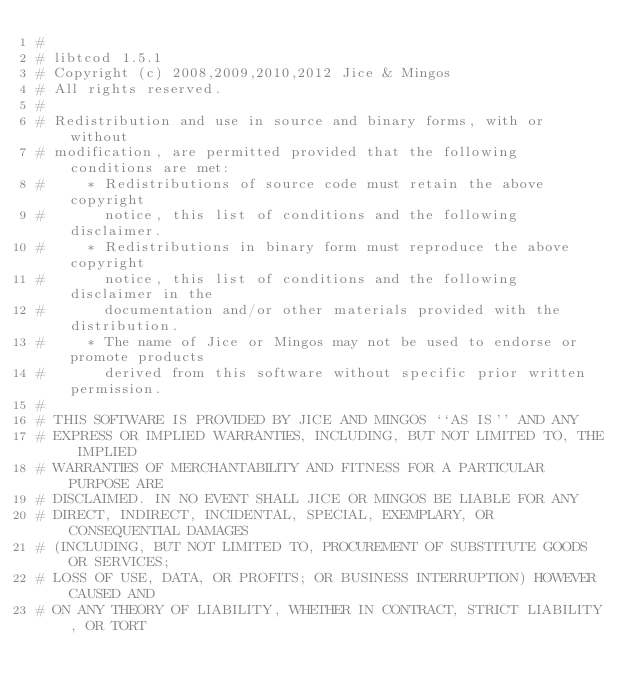Convert code to text. <code><loc_0><loc_0><loc_500><loc_500><_Nim_>#
# libtcod 1.5.1
# Copyright (c) 2008,2009,2010,2012 Jice & Mingos
# All rights reserved.
#
# Redistribution and use in source and binary forms, with or without
# modification, are permitted provided that the following conditions are met:
#     * Redistributions of source code must retain the above copyright
#       notice, this list of conditions and the following disclaimer.
#     * Redistributions in binary form must reproduce the above copyright
#       notice, this list of conditions and the following disclaimer in the
#       documentation and/or other materials provided with the distribution.
#     * The name of Jice or Mingos may not be used to endorse or promote products
#       derived from this software without specific prior written permission.
#
# THIS SOFTWARE IS PROVIDED BY JICE AND MINGOS ``AS IS'' AND ANY
# EXPRESS OR IMPLIED WARRANTIES, INCLUDING, BUT NOT LIMITED TO, THE IMPLIED
# WARRANTIES OF MERCHANTABILITY AND FITNESS FOR A PARTICULAR PURPOSE ARE
# DISCLAIMED. IN NO EVENT SHALL JICE OR MINGOS BE LIABLE FOR ANY
# DIRECT, INDIRECT, INCIDENTAL, SPECIAL, EXEMPLARY, OR CONSEQUENTIAL DAMAGES
# (INCLUDING, BUT NOT LIMITED TO, PROCUREMENT OF SUBSTITUTE GOODS OR SERVICES;
# LOSS OF USE, DATA, OR PROFITS; OR BUSINESS INTERRUPTION) HOWEVER CAUSED AND
# ON ANY THEORY OF LIABILITY, WHETHER IN CONTRACT, STRICT LIABILITY, OR TORT</code> 